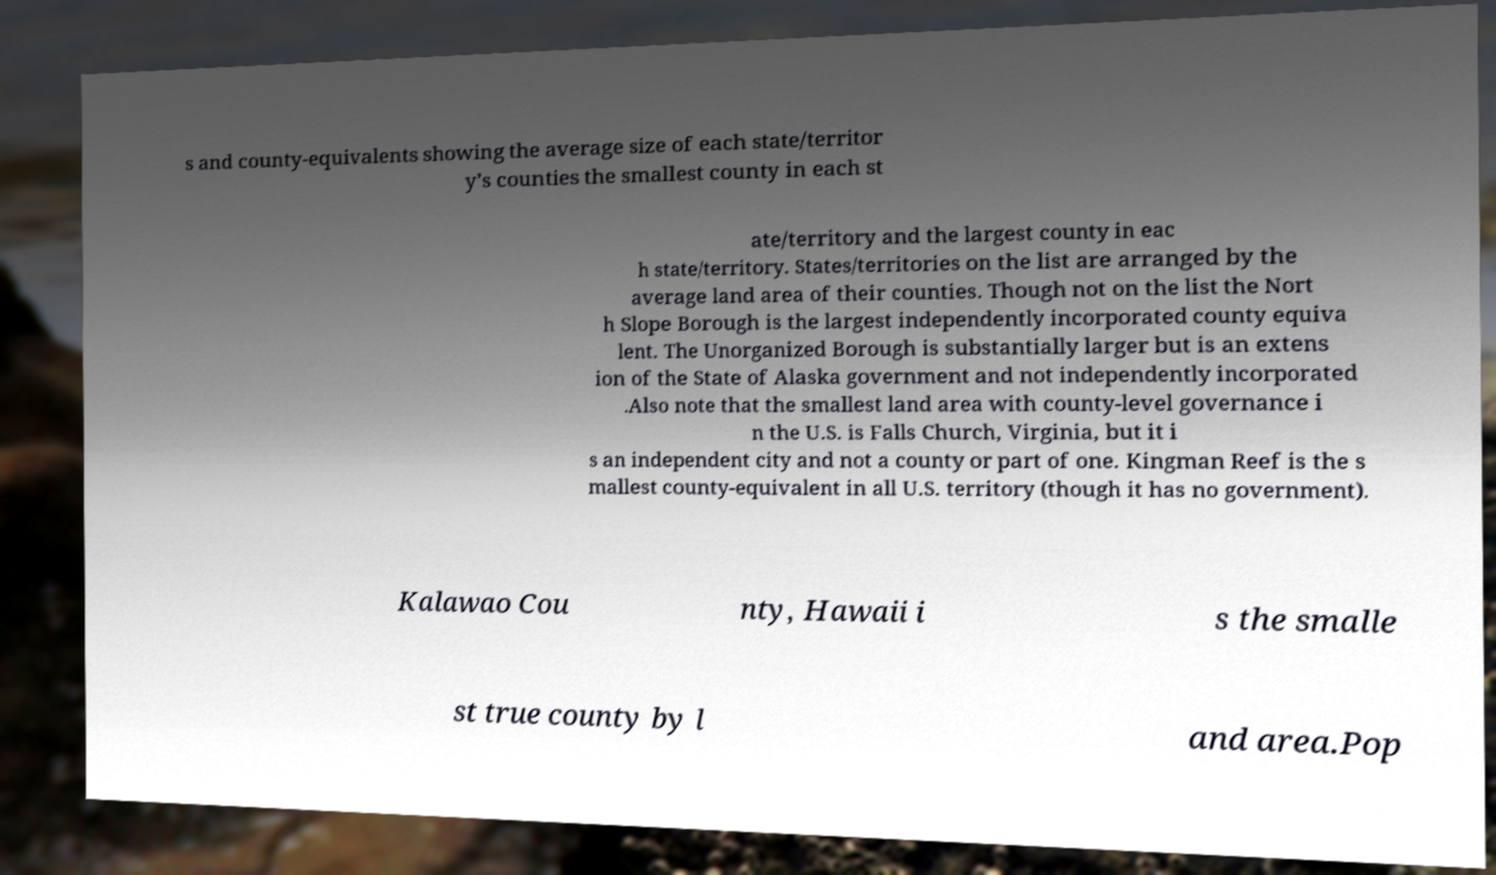Could you assist in decoding the text presented in this image and type it out clearly? s and county-equivalents showing the average size of each state/territor y’s counties the smallest county in each st ate/territory and the largest county in eac h state/territory. States/territories on the list are arranged by the average land area of their counties. Though not on the list the Nort h Slope Borough is the largest independently incorporated county equiva lent. The Unorganized Borough is substantially larger but is an extens ion of the State of Alaska government and not independently incorporated .Also note that the smallest land area with county-level governance i n the U.S. is Falls Church, Virginia, but it i s an independent city and not a county or part of one. Kingman Reef is the s mallest county-equivalent in all U.S. territory (though it has no government). Kalawao Cou nty, Hawaii i s the smalle st true county by l and area.Pop 